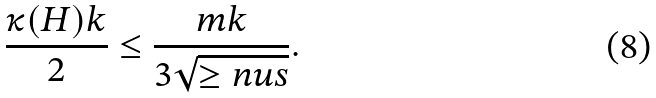Convert formula to latex. <formula><loc_0><loc_0><loc_500><loc_500>\frac { \kappa ( H ) k } { 2 } \leq \frac { m k } { 3 \sqrt { \geq n u s } } .</formula> 